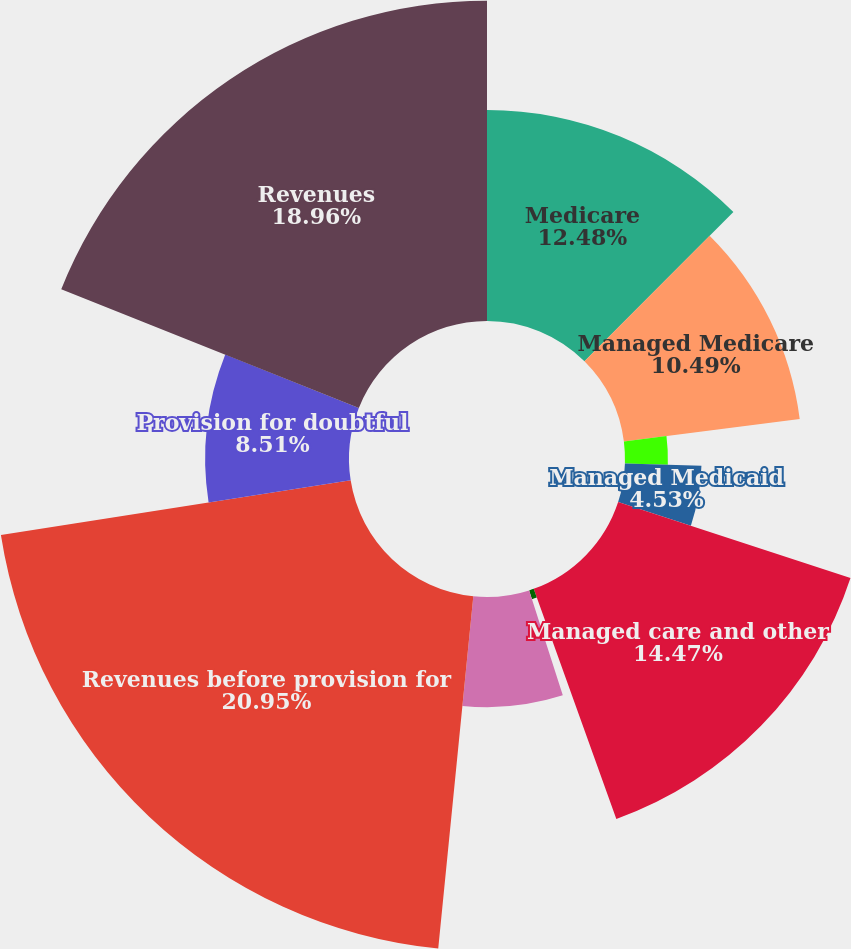<chart> <loc_0><loc_0><loc_500><loc_500><pie_chart><fcel>Medicare<fcel>Managed Medicare<fcel>Medicaid<fcel>Managed Medicaid<fcel>Managed care and other<fcel>International (managed care<fcel>Other<fcel>Revenues before provision for<fcel>Provision for doubtful<fcel>Revenues<nl><fcel>12.48%<fcel>10.49%<fcel>2.54%<fcel>4.53%<fcel>14.47%<fcel>0.55%<fcel>6.52%<fcel>20.95%<fcel>8.51%<fcel>18.96%<nl></chart> 